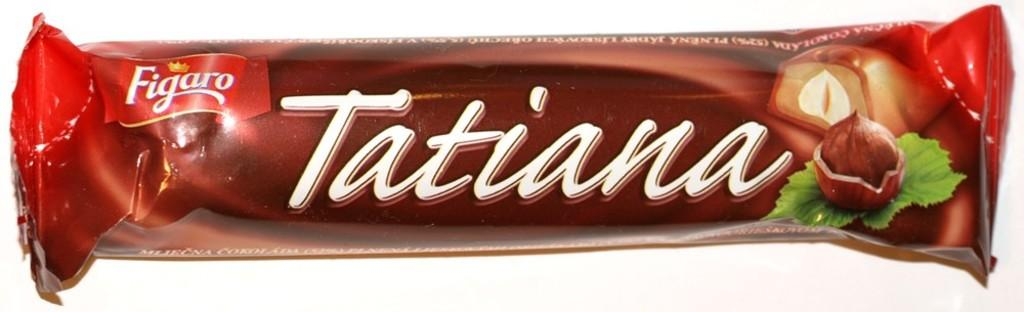What is the main subject of the image? The main subject of the image is a chocolate cover. What can be seen on the chocolate cover? There is text on the chocolate cover. What type of liquid is visible on the chocolate cover in the image? There is no liquid visible on the chocolate cover in the image. How many snakes can be seen slithering on the chocolate cover in the image? There are no snakes present on the chocolate cover in the image. What type of stem is connected to the chocolate cover in the image? There is no stem connected to the chocolate cover in the image. 